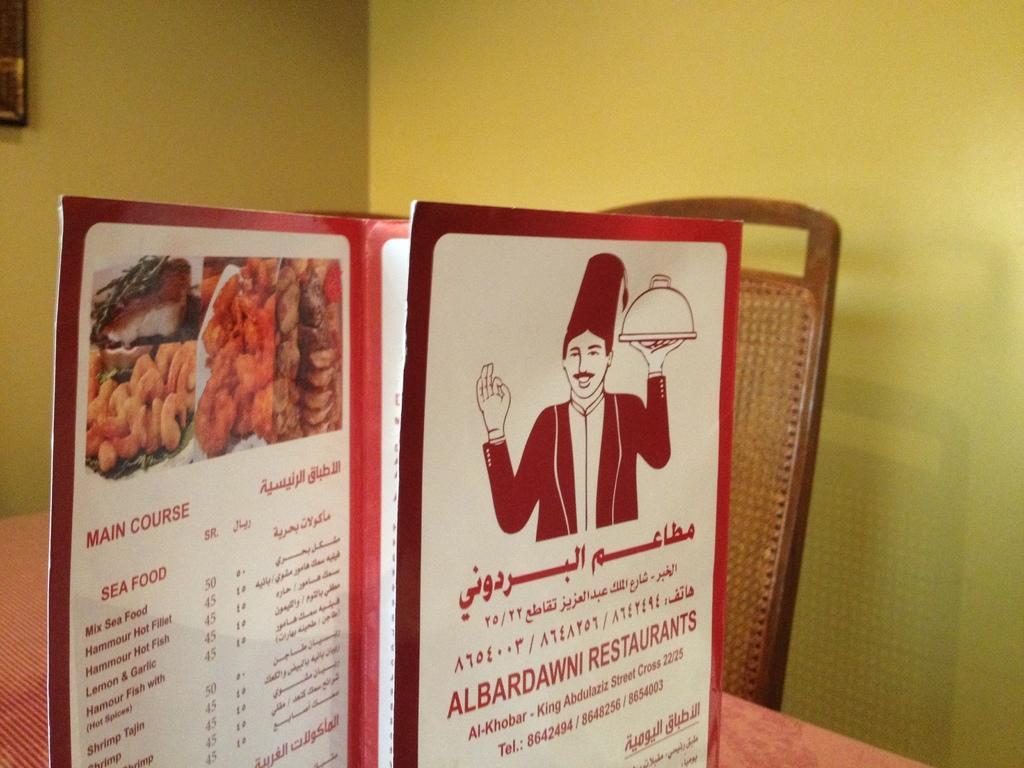How would you summarize this image in a sentence or two? In this picture we can see a menu card on the table and also I can see a chair, we can see frame to the wall. 